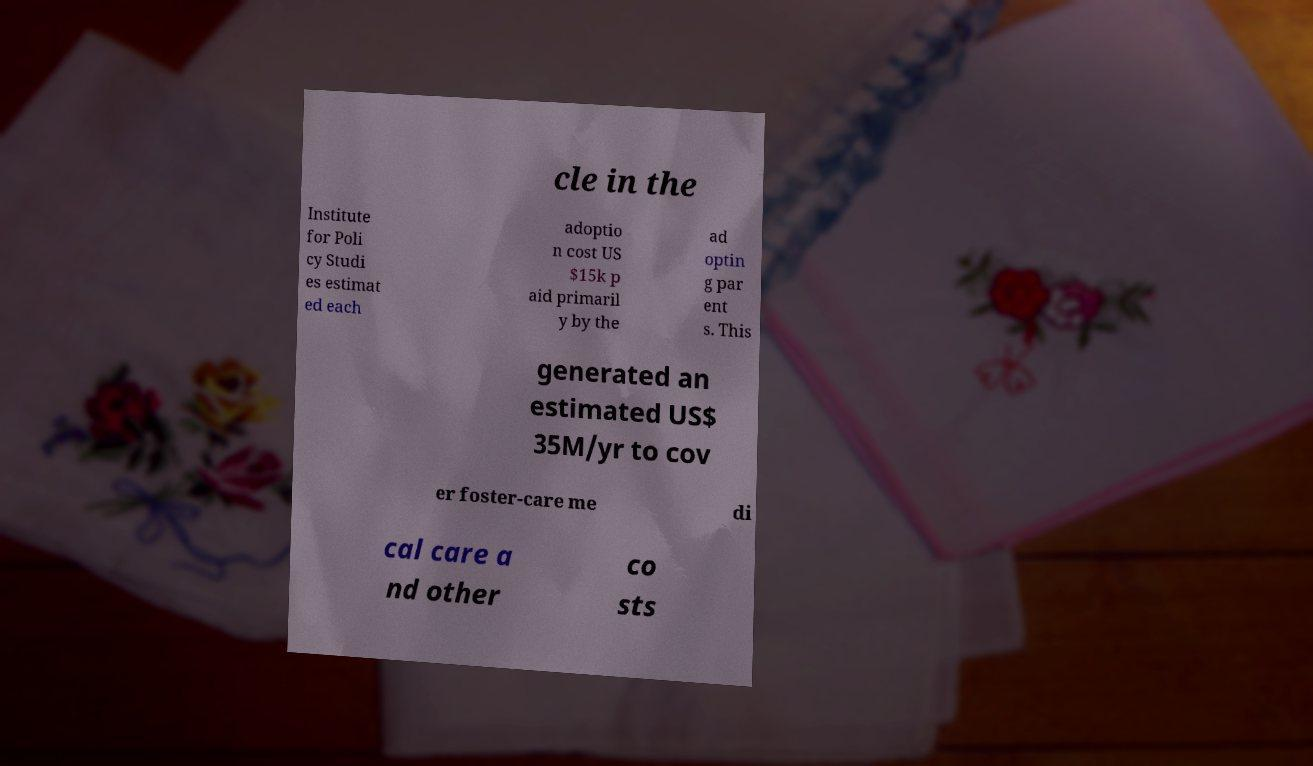What messages or text are displayed in this image? I need them in a readable, typed format. cle in the Institute for Poli cy Studi es estimat ed each adoptio n cost US $15k p aid primaril y by the ad optin g par ent s. This generated an estimated US$ 35M/yr to cov er foster-care me di cal care a nd other co sts 